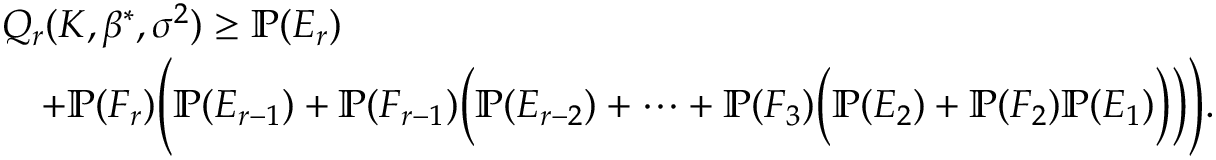<formula> <loc_0><loc_0><loc_500><loc_500>\begin{array} { r l } & { Q _ { r } ( K , \beta ^ { * } , \sigma ^ { 2 } ) \geq \mathbb { P } ( E _ { r } ) } \\ & { \quad + \mathbb { P } ( F _ { r } ) \left ( \mathbb { P } ( E _ { r - 1 } ) + \mathbb { P } ( F _ { r - 1 } ) \left ( \mathbb { P } ( E _ { r - 2 } ) + \cdots + \mathbb { P } ( F _ { 3 } ) \left ( \mathbb { P } ( E _ { 2 } ) + \mathbb { P } ( F _ { 2 } ) \mathbb { P } ( E _ { 1 } ) \right ) \right ) \right ) . } \end{array}</formula> 